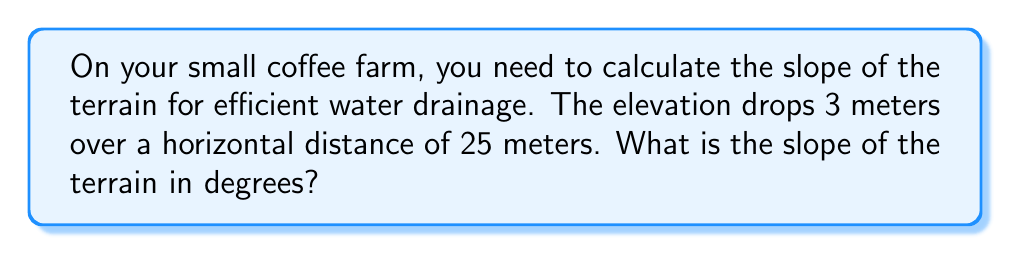What is the answer to this math problem? To find the slope in degrees, we'll follow these steps:

1. Calculate the slope as a ratio:
   Slope = Rise / Run = 3 m / 25 m = 0.12

2. The slope ratio represents the tangent of the angle. We need to find the angle whose tangent is 0.12:
   $\tan(\theta) = 0.12$

3. To solve for $\theta$, we use the inverse tangent (arctangent) function:
   $\theta = \tan^{-1}(0.12)$

4. Using a calculator or trigonometric tables:
   $\theta \approx 6.84°$

[asy]
import geometry;

size(200);
real angle = 6.84;
real hyp = 10;
real opp = hyp * sin(angle * pi / 180);
real adj = hyp * cos(angle * pi / 180);

draw((0,0)--(adj,0)--(adj,opp)--(0,0), arrow=Arrow(TeXHead));
label("25 m", (adj/2,0), S);
label("3 m", (adj,opp/2), E);
label("$\theta$", (0.5,0.5), NW);
</asy]

This angle represents the slope of your coffee field, which is crucial for ensuring proper water drainage and preventing erosion of your valuable topsoil.
Answer: $6.84°$ 